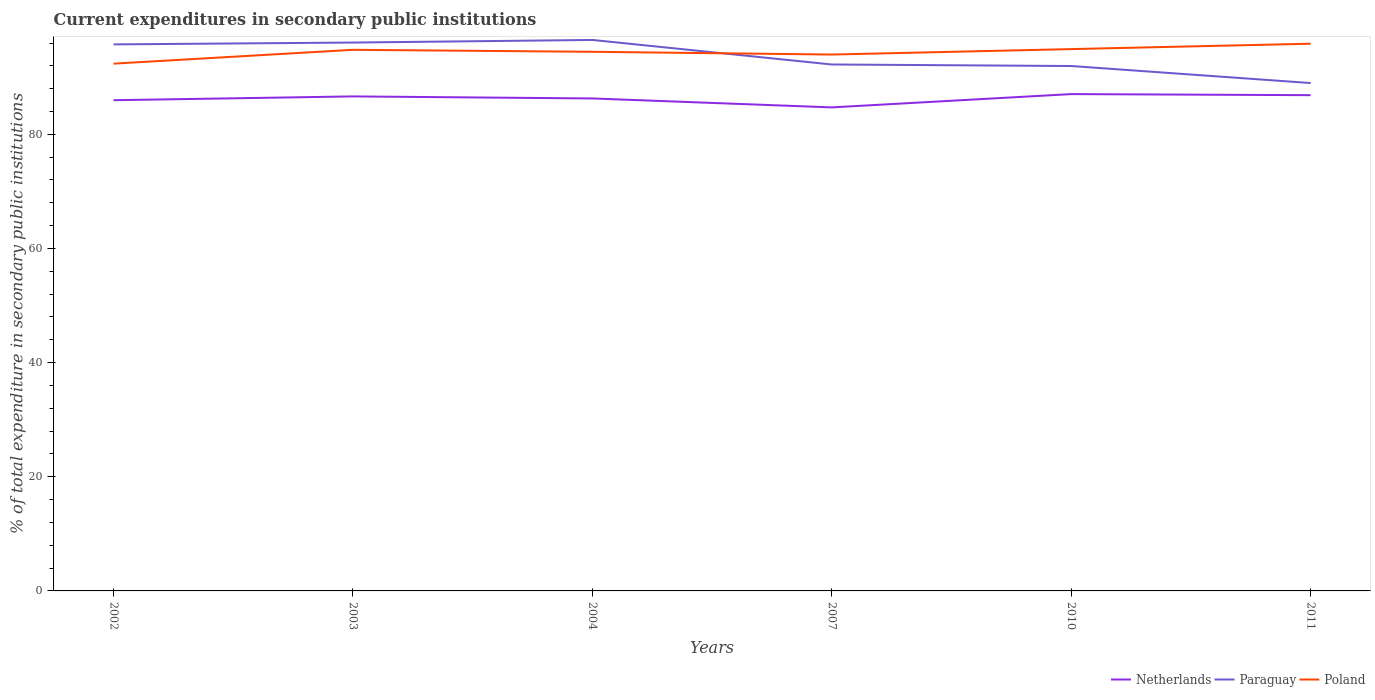Across all years, what is the maximum current expenditures in secondary public institutions in Paraguay?
Offer a terse response. 88.99. What is the total current expenditures in secondary public institutions in Netherlands in the graph?
Give a very brief answer. -0.22. What is the difference between the highest and the second highest current expenditures in secondary public institutions in Netherlands?
Offer a very short reply. 2.33. Does the graph contain grids?
Provide a short and direct response. No. Where does the legend appear in the graph?
Offer a very short reply. Bottom right. How many legend labels are there?
Ensure brevity in your answer.  3. What is the title of the graph?
Make the answer very short. Current expenditures in secondary public institutions. What is the label or title of the X-axis?
Keep it short and to the point. Years. What is the label or title of the Y-axis?
Give a very brief answer. % of total expenditure in secondary public institutions. What is the % of total expenditure in secondary public institutions of Netherlands in 2002?
Your answer should be very brief. 85.98. What is the % of total expenditure in secondary public institutions of Paraguay in 2002?
Offer a terse response. 95.76. What is the % of total expenditure in secondary public institutions in Poland in 2002?
Your answer should be compact. 92.39. What is the % of total expenditure in secondary public institutions in Netherlands in 2003?
Offer a very short reply. 86.65. What is the % of total expenditure in secondary public institutions in Paraguay in 2003?
Your answer should be very brief. 96.08. What is the % of total expenditure in secondary public institutions of Poland in 2003?
Make the answer very short. 94.81. What is the % of total expenditure in secondary public institutions in Netherlands in 2004?
Make the answer very short. 86.29. What is the % of total expenditure in secondary public institutions of Paraguay in 2004?
Provide a short and direct response. 96.54. What is the % of total expenditure in secondary public institutions of Poland in 2004?
Offer a very short reply. 94.46. What is the % of total expenditure in secondary public institutions of Netherlands in 2007?
Keep it short and to the point. 84.72. What is the % of total expenditure in secondary public institutions of Paraguay in 2007?
Your answer should be very brief. 92.24. What is the % of total expenditure in secondary public institutions of Poland in 2007?
Offer a very short reply. 93.98. What is the % of total expenditure in secondary public institutions of Netherlands in 2010?
Your response must be concise. 87.05. What is the % of total expenditure in secondary public institutions in Paraguay in 2010?
Your answer should be compact. 91.97. What is the % of total expenditure in secondary public institutions in Poland in 2010?
Offer a terse response. 94.94. What is the % of total expenditure in secondary public institutions of Netherlands in 2011?
Give a very brief answer. 86.86. What is the % of total expenditure in secondary public institutions of Paraguay in 2011?
Make the answer very short. 88.99. What is the % of total expenditure in secondary public institutions in Poland in 2011?
Offer a very short reply. 95.88. Across all years, what is the maximum % of total expenditure in secondary public institutions in Netherlands?
Give a very brief answer. 87.05. Across all years, what is the maximum % of total expenditure in secondary public institutions in Paraguay?
Your answer should be very brief. 96.54. Across all years, what is the maximum % of total expenditure in secondary public institutions in Poland?
Provide a short and direct response. 95.88. Across all years, what is the minimum % of total expenditure in secondary public institutions of Netherlands?
Give a very brief answer. 84.72. Across all years, what is the minimum % of total expenditure in secondary public institutions of Paraguay?
Your answer should be compact. 88.99. Across all years, what is the minimum % of total expenditure in secondary public institutions in Poland?
Keep it short and to the point. 92.39. What is the total % of total expenditure in secondary public institutions in Netherlands in the graph?
Offer a very short reply. 517.55. What is the total % of total expenditure in secondary public institutions of Paraguay in the graph?
Your answer should be compact. 561.58. What is the total % of total expenditure in secondary public institutions of Poland in the graph?
Your response must be concise. 566.45. What is the difference between the % of total expenditure in secondary public institutions in Netherlands in 2002 and that in 2003?
Keep it short and to the point. -0.66. What is the difference between the % of total expenditure in secondary public institutions of Paraguay in 2002 and that in 2003?
Your answer should be compact. -0.32. What is the difference between the % of total expenditure in secondary public institutions in Poland in 2002 and that in 2003?
Give a very brief answer. -2.42. What is the difference between the % of total expenditure in secondary public institutions in Netherlands in 2002 and that in 2004?
Provide a succinct answer. -0.31. What is the difference between the % of total expenditure in secondary public institutions in Paraguay in 2002 and that in 2004?
Your answer should be compact. -0.78. What is the difference between the % of total expenditure in secondary public institutions of Poland in 2002 and that in 2004?
Ensure brevity in your answer.  -2.08. What is the difference between the % of total expenditure in secondary public institutions in Netherlands in 2002 and that in 2007?
Give a very brief answer. 1.26. What is the difference between the % of total expenditure in secondary public institutions of Paraguay in 2002 and that in 2007?
Keep it short and to the point. 3.52. What is the difference between the % of total expenditure in secondary public institutions in Poland in 2002 and that in 2007?
Keep it short and to the point. -1.59. What is the difference between the % of total expenditure in secondary public institutions of Netherlands in 2002 and that in 2010?
Offer a terse response. -1.07. What is the difference between the % of total expenditure in secondary public institutions in Paraguay in 2002 and that in 2010?
Your response must be concise. 3.79. What is the difference between the % of total expenditure in secondary public institutions of Poland in 2002 and that in 2010?
Ensure brevity in your answer.  -2.55. What is the difference between the % of total expenditure in secondary public institutions of Netherlands in 2002 and that in 2011?
Your response must be concise. -0.88. What is the difference between the % of total expenditure in secondary public institutions of Paraguay in 2002 and that in 2011?
Your response must be concise. 6.77. What is the difference between the % of total expenditure in secondary public institutions of Poland in 2002 and that in 2011?
Give a very brief answer. -3.49. What is the difference between the % of total expenditure in secondary public institutions of Netherlands in 2003 and that in 2004?
Your response must be concise. 0.36. What is the difference between the % of total expenditure in secondary public institutions of Paraguay in 2003 and that in 2004?
Ensure brevity in your answer.  -0.46. What is the difference between the % of total expenditure in secondary public institutions in Poland in 2003 and that in 2004?
Your response must be concise. 0.35. What is the difference between the % of total expenditure in secondary public institutions in Netherlands in 2003 and that in 2007?
Provide a short and direct response. 1.92. What is the difference between the % of total expenditure in secondary public institutions in Paraguay in 2003 and that in 2007?
Provide a short and direct response. 3.84. What is the difference between the % of total expenditure in secondary public institutions of Poland in 2003 and that in 2007?
Your answer should be very brief. 0.83. What is the difference between the % of total expenditure in secondary public institutions of Netherlands in 2003 and that in 2010?
Provide a succinct answer. -0.4. What is the difference between the % of total expenditure in secondary public institutions of Paraguay in 2003 and that in 2010?
Offer a terse response. 4.11. What is the difference between the % of total expenditure in secondary public institutions of Poland in 2003 and that in 2010?
Offer a terse response. -0.13. What is the difference between the % of total expenditure in secondary public institutions of Netherlands in 2003 and that in 2011?
Provide a succinct answer. -0.22. What is the difference between the % of total expenditure in secondary public institutions in Paraguay in 2003 and that in 2011?
Your answer should be very brief. 7.1. What is the difference between the % of total expenditure in secondary public institutions in Poland in 2003 and that in 2011?
Provide a succinct answer. -1.07. What is the difference between the % of total expenditure in secondary public institutions of Netherlands in 2004 and that in 2007?
Make the answer very short. 1.57. What is the difference between the % of total expenditure in secondary public institutions in Paraguay in 2004 and that in 2007?
Offer a terse response. 4.3. What is the difference between the % of total expenditure in secondary public institutions of Poland in 2004 and that in 2007?
Your answer should be very brief. 0.48. What is the difference between the % of total expenditure in secondary public institutions in Netherlands in 2004 and that in 2010?
Keep it short and to the point. -0.76. What is the difference between the % of total expenditure in secondary public institutions in Paraguay in 2004 and that in 2010?
Provide a short and direct response. 4.57. What is the difference between the % of total expenditure in secondary public institutions in Poland in 2004 and that in 2010?
Offer a very short reply. -0.47. What is the difference between the % of total expenditure in secondary public institutions of Netherlands in 2004 and that in 2011?
Offer a terse response. -0.57. What is the difference between the % of total expenditure in secondary public institutions of Paraguay in 2004 and that in 2011?
Provide a succinct answer. 7.55. What is the difference between the % of total expenditure in secondary public institutions in Poland in 2004 and that in 2011?
Offer a very short reply. -1.42. What is the difference between the % of total expenditure in secondary public institutions of Netherlands in 2007 and that in 2010?
Give a very brief answer. -2.33. What is the difference between the % of total expenditure in secondary public institutions of Paraguay in 2007 and that in 2010?
Offer a very short reply. 0.27. What is the difference between the % of total expenditure in secondary public institutions of Poland in 2007 and that in 2010?
Provide a succinct answer. -0.96. What is the difference between the % of total expenditure in secondary public institutions of Netherlands in 2007 and that in 2011?
Your response must be concise. -2.14. What is the difference between the % of total expenditure in secondary public institutions in Paraguay in 2007 and that in 2011?
Ensure brevity in your answer.  3.25. What is the difference between the % of total expenditure in secondary public institutions in Poland in 2007 and that in 2011?
Your answer should be very brief. -1.9. What is the difference between the % of total expenditure in secondary public institutions of Netherlands in 2010 and that in 2011?
Offer a very short reply. 0.19. What is the difference between the % of total expenditure in secondary public institutions in Paraguay in 2010 and that in 2011?
Ensure brevity in your answer.  2.98. What is the difference between the % of total expenditure in secondary public institutions in Poland in 2010 and that in 2011?
Make the answer very short. -0.94. What is the difference between the % of total expenditure in secondary public institutions in Netherlands in 2002 and the % of total expenditure in secondary public institutions in Paraguay in 2003?
Offer a terse response. -10.1. What is the difference between the % of total expenditure in secondary public institutions of Netherlands in 2002 and the % of total expenditure in secondary public institutions of Poland in 2003?
Your answer should be very brief. -8.83. What is the difference between the % of total expenditure in secondary public institutions of Paraguay in 2002 and the % of total expenditure in secondary public institutions of Poland in 2003?
Offer a terse response. 0.95. What is the difference between the % of total expenditure in secondary public institutions of Netherlands in 2002 and the % of total expenditure in secondary public institutions of Paraguay in 2004?
Your answer should be compact. -10.56. What is the difference between the % of total expenditure in secondary public institutions of Netherlands in 2002 and the % of total expenditure in secondary public institutions of Poland in 2004?
Give a very brief answer. -8.48. What is the difference between the % of total expenditure in secondary public institutions in Paraguay in 2002 and the % of total expenditure in secondary public institutions in Poland in 2004?
Your answer should be very brief. 1.3. What is the difference between the % of total expenditure in secondary public institutions in Netherlands in 2002 and the % of total expenditure in secondary public institutions in Paraguay in 2007?
Your answer should be very brief. -6.26. What is the difference between the % of total expenditure in secondary public institutions of Netherlands in 2002 and the % of total expenditure in secondary public institutions of Poland in 2007?
Offer a terse response. -8. What is the difference between the % of total expenditure in secondary public institutions of Paraguay in 2002 and the % of total expenditure in secondary public institutions of Poland in 2007?
Your answer should be compact. 1.78. What is the difference between the % of total expenditure in secondary public institutions in Netherlands in 2002 and the % of total expenditure in secondary public institutions in Paraguay in 2010?
Give a very brief answer. -5.99. What is the difference between the % of total expenditure in secondary public institutions of Netherlands in 2002 and the % of total expenditure in secondary public institutions of Poland in 2010?
Provide a succinct answer. -8.95. What is the difference between the % of total expenditure in secondary public institutions in Paraguay in 2002 and the % of total expenditure in secondary public institutions in Poland in 2010?
Make the answer very short. 0.82. What is the difference between the % of total expenditure in secondary public institutions of Netherlands in 2002 and the % of total expenditure in secondary public institutions of Paraguay in 2011?
Provide a short and direct response. -3. What is the difference between the % of total expenditure in secondary public institutions of Netherlands in 2002 and the % of total expenditure in secondary public institutions of Poland in 2011?
Provide a short and direct response. -9.9. What is the difference between the % of total expenditure in secondary public institutions in Paraguay in 2002 and the % of total expenditure in secondary public institutions in Poland in 2011?
Provide a short and direct response. -0.12. What is the difference between the % of total expenditure in secondary public institutions in Netherlands in 2003 and the % of total expenditure in secondary public institutions in Paraguay in 2004?
Offer a very short reply. -9.89. What is the difference between the % of total expenditure in secondary public institutions in Netherlands in 2003 and the % of total expenditure in secondary public institutions in Poland in 2004?
Ensure brevity in your answer.  -7.82. What is the difference between the % of total expenditure in secondary public institutions of Paraguay in 2003 and the % of total expenditure in secondary public institutions of Poland in 2004?
Your answer should be compact. 1.62. What is the difference between the % of total expenditure in secondary public institutions in Netherlands in 2003 and the % of total expenditure in secondary public institutions in Paraguay in 2007?
Your answer should be compact. -5.59. What is the difference between the % of total expenditure in secondary public institutions in Netherlands in 2003 and the % of total expenditure in secondary public institutions in Poland in 2007?
Offer a very short reply. -7.33. What is the difference between the % of total expenditure in secondary public institutions of Paraguay in 2003 and the % of total expenditure in secondary public institutions of Poland in 2007?
Make the answer very short. 2.1. What is the difference between the % of total expenditure in secondary public institutions of Netherlands in 2003 and the % of total expenditure in secondary public institutions of Paraguay in 2010?
Your response must be concise. -5.32. What is the difference between the % of total expenditure in secondary public institutions of Netherlands in 2003 and the % of total expenditure in secondary public institutions of Poland in 2010?
Keep it short and to the point. -8.29. What is the difference between the % of total expenditure in secondary public institutions of Paraguay in 2003 and the % of total expenditure in secondary public institutions of Poland in 2010?
Provide a short and direct response. 1.15. What is the difference between the % of total expenditure in secondary public institutions in Netherlands in 2003 and the % of total expenditure in secondary public institutions in Paraguay in 2011?
Ensure brevity in your answer.  -2.34. What is the difference between the % of total expenditure in secondary public institutions of Netherlands in 2003 and the % of total expenditure in secondary public institutions of Poland in 2011?
Provide a short and direct response. -9.23. What is the difference between the % of total expenditure in secondary public institutions in Paraguay in 2003 and the % of total expenditure in secondary public institutions in Poland in 2011?
Your response must be concise. 0.21. What is the difference between the % of total expenditure in secondary public institutions of Netherlands in 2004 and the % of total expenditure in secondary public institutions of Paraguay in 2007?
Ensure brevity in your answer.  -5.95. What is the difference between the % of total expenditure in secondary public institutions of Netherlands in 2004 and the % of total expenditure in secondary public institutions of Poland in 2007?
Offer a terse response. -7.69. What is the difference between the % of total expenditure in secondary public institutions of Paraguay in 2004 and the % of total expenditure in secondary public institutions of Poland in 2007?
Make the answer very short. 2.56. What is the difference between the % of total expenditure in secondary public institutions of Netherlands in 2004 and the % of total expenditure in secondary public institutions of Paraguay in 2010?
Your answer should be compact. -5.68. What is the difference between the % of total expenditure in secondary public institutions in Netherlands in 2004 and the % of total expenditure in secondary public institutions in Poland in 2010?
Offer a very short reply. -8.65. What is the difference between the % of total expenditure in secondary public institutions in Paraguay in 2004 and the % of total expenditure in secondary public institutions in Poland in 2010?
Ensure brevity in your answer.  1.6. What is the difference between the % of total expenditure in secondary public institutions of Netherlands in 2004 and the % of total expenditure in secondary public institutions of Paraguay in 2011?
Your answer should be very brief. -2.7. What is the difference between the % of total expenditure in secondary public institutions of Netherlands in 2004 and the % of total expenditure in secondary public institutions of Poland in 2011?
Offer a very short reply. -9.59. What is the difference between the % of total expenditure in secondary public institutions of Paraguay in 2004 and the % of total expenditure in secondary public institutions of Poland in 2011?
Offer a terse response. 0.66. What is the difference between the % of total expenditure in secondary public institutions in Netherlands in 2007 and the % of total expenditure in secondary public institutions in Paraguay in 2010?
Offer a very short reply. -7.25. What is the difference between the % of total expenditure in secondary public institutions of Netherlands in 2007 and the % of total expenditure in secondary public institutions of Poland in 2010?
Your answer should be compact. -10.21. What is the difference between the % of total expenditure in secondary public institutions of Paraguay in 2007 and the % of total expenditure in secondary public institutions of Poland in 2010?
Your answer should be compact. -2.7. What is the difference between the % of total expenditure in secondary public institutions of Netherlands in 2007 and the % of total expenditure in secondary public institutions of Paraguay in 2011?
Your response must be concise. -4.26. What is the difference between the % of total expenditure in secondary public institutions of Netherlands in 2007 and the % of total expenditure in secondary public institutions of Poland in 2011?
Offer a very short reply. -11.16. What is the difference between the % of total expenditure in secondary public institutions of Paraguay in 2007 and the % of total expenditure in secondary public institutions of Poland in 2011?
Your answer should be very brief. -3.64. What is the difference between the % of total expenditure in secondary public institutions in Netherlands in 2010 and the % of total expenditure in secondary public institutions in Paraguay in 2011?
Make the answer very short. -1.94. What is the difference between the % of total expenditure in secondary public institutions in Netherlands in 2010 and the % of total expenditure in secondary public institutions in Poland in 2011?
Provide a short and direct response. -8.83. What is the difference between the % of total expenditure in secondary public institutions of Paraguay in 2010 and the % of total expenditure in secondary public institutions of Poland in 2011?
Offer a very short reply. -3.91. What is the average % of total expenditure in secondary public institutions of Netherlands per year?
Offer a very short reply. 86.26. What is the average % of total expenditure in secondary public institutions in Paraguay per year?
Give a very brief answer. 93.6. What is the average % of total expenditure in secondary public institutions in Poland per year?
Provide a short and direct response. 94.41. In the year 2002, what is the difference between the % of total expenditure in secondary public institutions of Netherlands and % of total expenditure in secondary public institutions of Paraguay?
Offer a terse response. -9.78. In the year 2002, what is the difference between the % of total expenditure in secondary public institutions in Netherlands and % of total expenditure in secondary public institutions in Poland?
Ensure brevity in your answer.  -6.4. In the year 2002, what is the difference between the % of total expenditure in secondary public institutions of Paraguay and % of total expenditure in secondary public institutions of Poland?
Make the answer very short. 3.37. In the year 2003, what is the difference between the % of total expenditure in secondary public institutions in Netherlands and % of total expenditure in secondary public institutions in Paraguay?
Ensure brevity in your answer.  -9.44. In the year 2003, what is the difference between the % of total expenditure in secondary public institutions of Netherlands and % of total expenditure in secondary public institutions of Poland?
Your answer should be very brief. -8.16. In the year 2003, what is the difference between the % of total expenditure in secondary public institutions in Paraguay and % of total expenditure in secondary public institutions in Poland?
Provide a short and direct response. 1.27. In the year 2004, what is the difference between the % of total expenditure in secondary public institutions of Netherlands and % of total expenditure in secondary public institutions of Paraguay?
Make the answer very short. -10.25. In the year 2004, what is the difference between the % of total expenditure in secondary public institutions in Netherlands and % of total expenditure in secondary public institutions in Poland?
Your answer should be compact. -8.17. In the year 2004, what is the difference between the % of total expenditure in secondary public institutions of Paraguay and % of total expenditure in secondary public institutions of Poland?
Ensure brevity in your answer.  2.08. In the year 2007, what is the difference between the % of total expenditure in secondary public institutions of Netherlands and % of total expenditure in secondary public institutions of Paraguay?
Your answer should be compact. -7.52. In the year 2007, what is the difference between the % of total expenditure in secondary public institutions of Netherlands and % of total expenditure in secondary public institutions of Poland?
Give a very brief answer. -9.26. In the year 2007, what is the difference between the % of total expenditure in secondary public institutions of Paraguay and % of total expenditure in secondary public institutions of Poland?
Your response must be concise. -1.74. In the year 2010, what is the difference between the % of total expenditure in secondary public institutions of Netherlands and % of total expenditure in secondary public institutions of Paraguay?
Offer a very short reply. -4.92. In the year 2010, what is the difference between the % of total expenditure in secondary public institutions of Netherlands and % of total expenditure in secondary public institutions of Poland?
Provide a short and direct response. -7.89. In the year 2010, what is the difference between the % of total expenditure in secondary public institutions of Paraguay and % of total expenditure in secondary public institutions of Poland?
Keep it short and to the point. -2.97. In the year 2011, what is the difference between the % of total expenditure in secondary public institutions of Netherlands and % of total expenditure in secondary public institutions of Paraguay?
Keep it short and to the point. -2.12. In the year 2011, what is the difference between the % of total expenditure in secondary public institutions of Netherlands and % of total expenditure in secondary public institutions of Poland?
Provide a succinct answer. -9.02. In the year 2011, what is the difference between the % of total expenditure in secondary public institutions in Paraguay and % of total expenditure in secondary public institutions in Poland?
Make the answer very short. -6.89. What is the ratio of the % of total expenditure in secondary public institutions of Netherlands in 2002 to that in 2003?
Your response must be concise. 0.99. What is the ratio of the % of total expenditure in secondary public institutions of Paraguay in 2002 to that in 2003?
Give a very brief answer. 1. What is the ratio of the % of total expenditure in secondary public institutions in Poland in 2002 to that in 2003?
Ensure brevity in your answer.  0.97. What is the ratio of the % of total expenditure in secondary public institutions of Paraguay in 2002 to that in 2004?
Your response must be concise. 0.99. What is the ratio of the % of total expenditure in secondary public institutions of Netherlands in 2002 to that in 2007?
Your response must be concise. 1.01. What is the ratio of the % of total expenditure in secondary public institutions in Paraguay in 2002 to that in 2007?
Your response must be concise. 1.04. What is the ratio of the % of total expenditure in secondary public institutions in Poland in 2002 to that in 2007?
Keep it short and to the point. 0.98. What is the ratio of the % of total expenditure in secondary public institutions of Netherlands in 2002 to that in 2010?
Your answer should be very brief. 0.99. What is the ratio of the % of total expenditure in secondary public institutions of Paraguay in 2002 to that in 2010?
Make the answer very short. 1.04. What is the ratio of the % of total expenditure in secondary public institutions of Poland in 2002 to that in 2010?
Offer a terse response. 0.97. What is the ratio of the % of total expenditure in secondary public institutions of Netherlands in 2002 to that in 2011?
Provide a short and direct response. 0.99. What is the ratio of the % of total expenditure in secondary public institutions in Paraguay in 2002 to that in 2011?
Make the answer very short. 1.08. What is the ratio of the % of total expenditure in secondary public institutions of Poland in 2002 to that in 2011?
Make the answer very short. 0.96. What is the ratio of the % of total expenditure in secondary public institutions of Netherlands in 2003 to that in 2004?
Offer a very short reply. 1. What is the ratio of the % of total expenditure in secondary public institutions of Paraguay in 2003 to that in 2004?
Keep it short and to the point. 1. What is the ratio of the % of total expenditure in secondary public institutions in Poland in 2003 to that in 2004?
Make the answer very short. 1. What is the ratio of the % of total expenditure in secondary public institutions in Netherlands in 2003 to that in 2007?
Provide a succinct answer. 1.02. What is the ratio of the % of total expenditure in secondary public institutions in Paraguay in 2003 to that in 2007?
Your answer should be very brief. 1.04. What is the ratio of the % of total expenditure in secondary public institutions in Poland in 2003 to that in 2007?
Your answer should be compact. 1.01. What is the ratio of the % of total expenditure in secondary public institutions of Paraguay in 2003 to that in 2010?
Ensure brevity in your answer.  1.04. What is the ratio of the % of total expenditure in secondary public institutions of Paraguay in 2003 to that in 2011?
Keep it short and to the point. 1.08. What is the ratio of the % of total expenditure in secondary public institutions in Poland in 2003 to that in 2011?
Keep it short and to the point. 0.99. What is the ratio of the % of total expenditure in secondary public institutions of Netherlands in 2004 to that in 2007?
Offer a very short reply. 1.02. What is the ratio of the % of total expenditure in secondary public institutions of Paraguay in 2004 to that in 2007?
Provide a succinct answer. 1.05. What is the ratio of the % of total expenditure in secondary public institutions of Poland in 2004 to that in 2007?
Your answer should be compact. 1.01. What is the ratio of the % of total expenditure in secondary public institutions in Paraguay in 2004 to that in 2010?
Offer a very short reply. 1.05. What is the ratio of the % of total expenditure in secondary public institutions of Netherlands in 2004 to that in 2011?
Offer a very short reply. 0.99. What is the ratio of the % of total expenditure in secondary public institutions in Paraguay in 2004 to that in 2011?
Provide a short and direct response. 1.08. What is the ratio of the % of total expenditure in secondary public institutions in Poland in 2004 to that in 2011?
Offer a very short reply. 0.99. What is the ratio of the % of total expenditure in secondary public institutions of Netherlands in 2007 to that in 2010?
Your response must be concise. 0.97. What is the ratio of the % of total expenditure in secondary public institutions of Poland in 2007 to that in 2010?
Ensure brevity in your answer.  0.99. What is the ratio of the % of total expenditure in secondary public institutions of Netherlands in 2007 to that in 2011?
Your answer should be very brief. 0.98. What is the ratio of the % of total expenditure in secondary public institutions in Paraguay in 2007 to that in 2011?
Provide a succinct answer. 1.04. What is the ratio of the % of total expenditure in secondary public institutions in Poland in 2007 to that in 2011?
Ensure brevity in your answer.  0.98. What is the ratio of the % of total expenditure in secondary public institutions of Netherlands in 2010 to that in 2011?
Your response must be concise. 1. What is the ratio of the % of total expenditure in secondary public institutions of Paraguay in 2010 to that in 2011?
Offer a terse response. 1.03. What is the ratio of the % of total expenditure in secondary public institutions in Poland in 2010 to that in 2011?
Ensure brevity in your answer.  0.99. What is the difference between the highest and the second highest % of total expenditure in secondary public institutions of Netherlands?
Your answer should be very brief. 0.19. What is the difference between the highest and the second highest % of total expenditure in secondary public institutions of Paraguay?
Ensure brevity in your answer.  0.46. What is the difference between the highest and the second highest % of total expenditure in secondary public institutions of Poland?
Provide a succinct answer. 0.94. What is the difference between the highest and the lowest % of total expenditure in secondary public institutions of Netherlands?
Your response must be concise. 2.33. What is the difference between the highest and the lowest % of total expenditure in secondary public institutions of Paraguay?
Provide a short and direct response. 7.55. What is the difference between the highest and the lowest % of total expenditure in secondary public institutions in Poland?
Provide a succinct answer. 3.49. 